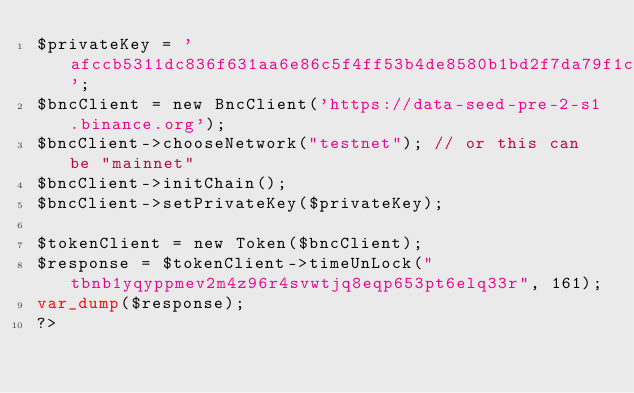<code> <loc_0><loc_0><loc_500><loc_500><_PHP_>$privateKey = 'afccb5311dc836f631aa6e86c5f4ff53b4de8580b1bd2f7da79f1cba910e5bff';
$bncClient = new BncClient('https://data-seed-pre-2-s1.binance.org');
$bncClient->chooseNetwork("testnet"); // or this can be "mainnet"
$bncClient->initChain();
$bncClient->setPrivateKey($privateKey);

$tokenClient = new Token($bncClient);
$response = $tokenClient->timeUnLock("tbnb1yqyppmev2m4z96r4svwtjq8eqp653pt6elq33r", 161);
var_dump($response);
?></code> 